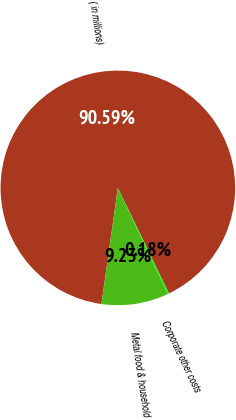Convert chart to OTSL. <chart><loc_0><loc_0><loc_500><loc_500><pie_chart><fcel>( in millions)<fcel>Metal food & household<fcel>Corporate other costs<nl><fcel>90.59%<fcel>9.23%<fcel>0.18%<nl></chart> 